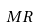Convert formula to latex. <formula><loc_0><loc_0><loc_500><loc_500>M R</formula> 